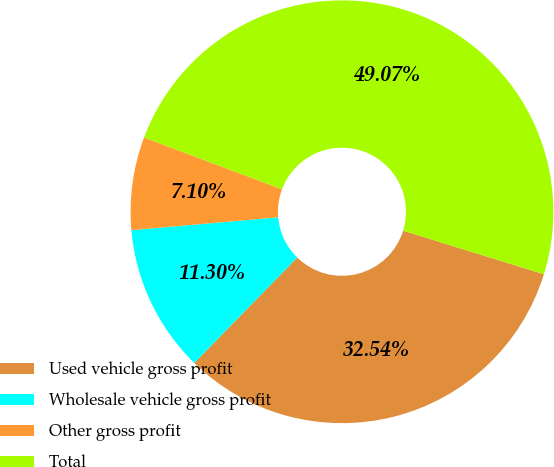Convert chart. <chart><loc_0><loc_0><loc_500><loc_500><pie_chart><fcel>Used vehicle gross profit<fcel>Wholesale vehicle gross profit<fcel>Other gross profit<fcel>Total<nl><fcel>32.54%<fcel>11.3%<fcel>7.1%<fcel>49.07%<nl></chart> 